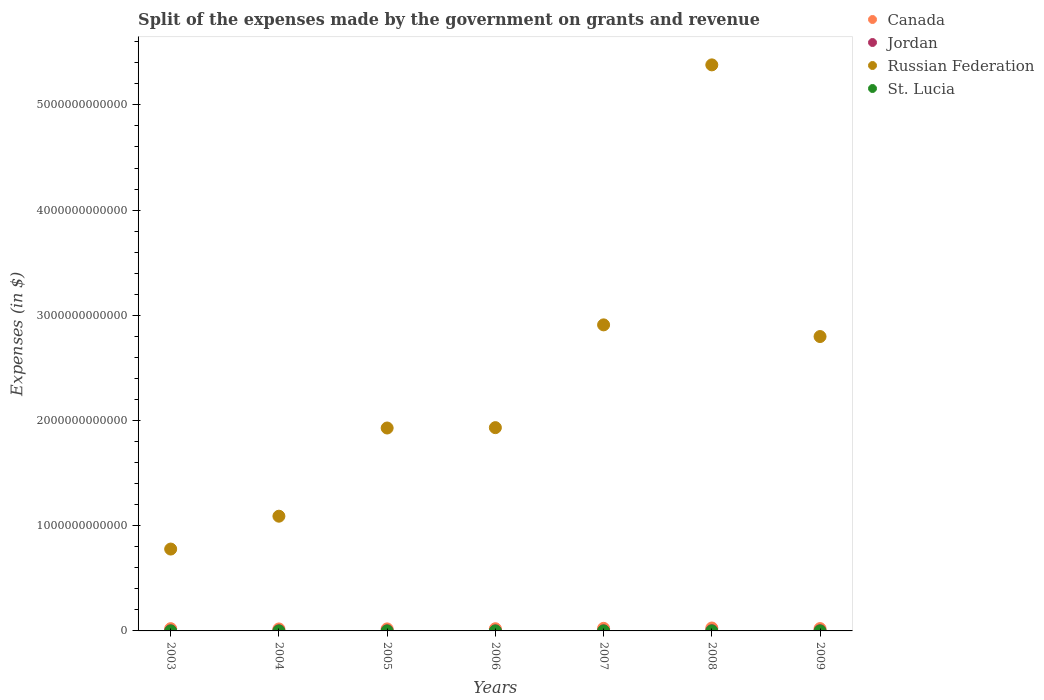How many different coloured dotlines are there?
Provide a succinct answer. 4. Is the number of dotlines equal to the number of legend labels?
Give a very brief answer. Yes. What is the expenses made by the government on grants and revenue in Jordan in 2005?
Your answer should be compact. 8.67e+08. Across all years, what is the maximum expenses made by the government on grants and revenue in Canada?
Provide a succinct answer. 2.77e+1. Across all years, what is the minimum expenses made by the government on grants and revenue in Canada?
Make the answer very short. 1.88e+1. What is the total expenses made by the government on grants and revenue in Russian Federation in the graph?
Offer a terse response. 1.68e+13. What is the difference between the expenses made by the government on grants and revenue in Russian Federation in 2003 and that in 2004?
Offer a very short reply. -3.12e+11. What is the difference between the expenses made by the government on grants and revenue in Jordan in 2003 and the expenses made by the government on grants and revenue in Canada in 2005?
Keep it short and to the point. -1.82e+1. What is the average expenses made by the government on grants and revenue in Russian Federation per year?
Provide a short and direct response. 2.40e+12. In the year 2005, what is the difference between the expenses made by the government on grants and revenue in Canada and expenses made by the government on grants and revenue in St. Lucia?
Your answer should be very brief. 1.92e+1. In how many years, is the expenses made by the government on grants and revenue in Canada greater than 1200000000000 $?
Ensure brevity in your answer.  0. What is the ratio of the expenses made by the government on grants and revenue in Canada in 2006 to that in 2009?
Provide a succinct answer. 0.94. What is the difference between the highest and the second highest expenses made by the government on grants and revenue in Russian Federation?
Provide a short and direct response. 2.47e+12. What is the difference between the highest and the lowest expenses made by the government on grants and revenue in Russian Federation?
Give a very brief answer. 4.60e+12. Is the sum of the expenses made by the government on grants and revenue in Russian Federation in 2003 and 2009 greater than the maximum expenses made by the government on grants and revenue in Canada across all years?
Your answer should be very brief. Yes. Is it the case that in every year, the sum of the expenses made by the government on grants and revenue in Jordan and expenses made by the government on grants and revenue in Russian Federation  is greater than the sum of expenses made by the government on grants and revenue in St. Lucia and expenses made by the government on grants and revenue in Canada?
Give a very brief answer. Yes. Is it the case that in every year, the sum of the expenses made by the government on grants and revenue in St. Lucia and expenses made by the government on grants and revenue in Canada  is greater than the expenses made by the government on grants and revenue in Jordan?
Offer a very short reply. Yes. Does the expenses made by the government on grants and revenue in Canada monotonically increase over the years?
Your answer should be very brief. No. Is the expenses made by the government on grants and revenue in Canada strictly less than the expenses made by the government on grants and revenue in St. Lucia over the years?
Your answer should be very brief. No. How many dotlines are there?
Your answer should be very brief. 4. What is the difference between two consecutive major ticks on the Y-axis?
Ensure brevity in your answer.  1.00e+12. Does the graph contain grids?
Your answer should be compact. No. How are the legend labels stacked?
Your answer should be very brief. Vertical. What is the title of the graph?
Your answer should be compact. Split of the expenses made by the government on grants and revenue. Does "Belgium" appear as one of the legend labels in the graph?
Offer a terse response. No. What is the label or title of the Y-axis?
Provide a short and direct response. Expenses (in $). What is the Expenses (in $) of Canada in 2003?
Ensure brevity in your answer.  2.14e+1. What is the Expenses (in $) of Jordan in 2003?
Your answer should be compact. 1.03e+09. What is the Expenses (in $) in Russian Federation in 2003?
Provide a succinct answer. 7.78e+11. What is the Expenses (in $) of St. Lucia in 2003?
Provide a succinct answer. 4.30e+07. What is the Expenses (in $) of Canada in 2004?
Offer a very short reply. 1.88e+1. What is the Expenses (in $) of Jordan in 2004?
Your answer should be very brief. 1.04e+09. What is the Expenses (in $) in Russian Federation in 2004?
Provide a short and direct response. 1.09e+12. What is the Expenses (in $) in Canada in 2005?
Offer a terse response. 1.92e+1. What is the Expenses (in $) of Jordan in 2005?
Offer a very short reply. 8.67e+08. What is the Expenses (in $) in Russian Federation in 2005?
Ensure brevity in your answer.  1.93e+12. What is the Expenses (in $) of St. Lucia in 2005?
Offer a very short reply. 4.20e+06. What is the Expenses (in $) in Canada in 2006?
Offer a very short reply. 2.09e+1. What is the Expenses (in $) of Jordan in 2006?
Offer a terse response. 8.31e+08. What is the Expenses (in $) of Russian Federation in 2006?
Your response must be concise. 1.93e+12. What is the Expenses (in $) of St. Lucia in 2006?
Keep it short and to the point. 3.30e+06. What is the Expenses (in $) in Canada in 2007?
Give a very brief answer. 2.45e+1. What is the Expenses (in $) in Jordan in 2007?
Your response must be concise. 9.58e+08. What is the Expenses (in $) of Russian Federation in 2007?
Give a very brief answer. 2.91e+12. What is the Expenses (in $) of St. Lucia in 2007?
Provide a short and direct response. 9.30e+06. What is the Expenses (in $) of Canada in 2008?
Provide a succinct answer. 2.77e+1. What is the Expenses (in $) of Jordan in 2008?
Your response must be concise. 1.96e+09. What is the Expenses (in $) of Russian Federation in 2008?
Give a very brief answer. 5.38e+12. What is the Expenses (in $) of St. Lucia in 2008?
Your answer should be compact. 2.07e+07. What is the Expenses (in $) in Canada in 2009?
Offer a very short reply. 2.21e+1. What is the Expenses (in $) in Jordan in 2009?
Keep it short and to the point. 1.62e+09. What is the Expenses (in $) in Russian Federation in 2009?
Provide a succinct answer. 2.80e+12. What is the Expenses (in $) of St. Lucia in 2009?
Offer a very short reply. 2.59e+07. Across all years, what is the maximum Expenses (in $) of Canada?
Provide a short and direct response. 2.77e+1. Across all years, what is the maximum Expenses (in $) in Jordan?
Ensure brevity in your answer.  1.96e+09. Across all years, what is the maximum Expenses (in $) of Russian Federation?
Provide a short and direct response. 5.38e+12. Across all years, what is the maximum Expenses (in $) in St. Lucia?
Give a very brief answer. 4.30e+07. Across all years, what is the minimum Expenses (in $) in Canada?
Provide a short and direct response. 1.88e+1. Across all years, what is the minimum Expenses (in $) of Jordan?
Provide a succinct answer. 8.31e+08. Across all years, what is the minimum Expenses (in $) of Russian Federation?
Make the answer very short. 7.78e+11. Across all years, what is the minimum Expenses (in $) of St. Lucia?
Make the answer very short. 3.30e+06. What is the total Expenses (in $) of Canada in the graph?
Make the answer very short. 1.55e+11. What is the total Expenses (in $) in Jordan in the graph?
Offer a very short reply. 8.30e+09. What is the total Expenses (in $) in Russian Federation in the graph?
Provide a succinct answer. 1.68e+13. What is the total Expenses (in $) in St. Lucia in the graph?
Offer a very short reply. 1.12e+08. What is the difference between the Expenses (in $) in Canada in 2003 and that in 2004?
Offer a terse response. 2.53e+09. What is the difference between the Expenses (in $) in Jordan in 2003 and that in 2004?
Your answer should be compact. -9.27e+06. What is the difference between the Expenses (in $) of Russian Federation in 2003 and that in 2004?
Your answer should be compact. -3.12e+11. What is the difference between the Expenses (in $) in St. Lucia in 2003 and that in 2004?
Give a very brief answer. 3.70e+07. What is the difference between the Expenses (in $) of Canada in 2003 and that in 2005?
Offer a very short reply. 2.18e+09. What is the difference between the Expenses (in $) of Jordan in 2003 and that in 2005?
Your response must be concise. 1.62e+08. What is the difference between the Expenses (in $) of Russian Federation in 2003 and that in 2005?
Provide a short and direct response. -1.15e+12. What is the difference between the Expenses (in $) of St. Lucia in 2003 and that in 2005?
Keep it short and to the point. 3.88e+07. What is the difference between the Expenses (in $) of Canada in 2003 and that in 2006?
Provide a succinct answer. 4.96e+08. What is the difference between the Expenses (in $) in Jordan in 2003 and that in 2006?
Make the answer very short. 1.98e+08. What is the difference between the Expenses (in $) in Russian Federation in 2003 and that in 2006?
Keep it short and to the point. -1.15e+12. What is the difference between the Expenses (in $) in St. Lucia in 2003 and that in 2006?
Provide a succinct answer. 3.97e+07. What is the difference between the Expenses (in $) in Canada in 2003 and that in 2007?
Keep it short and to the point. -3.13e+09. What is the difference between the Expenses (in $) in Jordan in 2003 and that in 2007?
Your answer should be very brief. 7.03e+07. What is the difference between the Expenses (in $) of Russian Federation in 2003 and that in 2007?
Give a very brief answer. -2.13e+12. What is the difference between the Expenses (in $) in St. Lucia in 2003 and that in 2007?
Make the answer very short. 3.37e+07. What is the difference between the Expenses (in $) of Canada in 2003 and that in 2008?
Offer a terse response. -6.36e+09. What is the difference between the Expenses (in $) in Jordan in 2003 and that in 2008?
Give a very brief answer. -9.31e+08. What is the difference between the Expenses (in $) of Russian Federation in 2003 and that in 2008?
Your response must be concise. -4.60e+12. What is the difference between the Expenses (in $) of St. Lucia in 2003 and that in 2008?
Your answer should be compact. 2.23e+07. What is the difference between the Expenses (in $) in Canada in 2003 and that in 2009?
Your response must be concise. -7.74e+08. What is the difference between the Expenses (in $) of Jordan in 2003 and that in 2009?
Provide a short and direct response. -5.93e+08. What is the difference between the Expenses (in $) of Russian Federation in 2003 and that in 2009?
Provide a succinct answer. -2.02e+12. What is the difference between the Expenses (in $) of St. Lucia in 2003 and that in 2009?
Ensure brevity in your answer.  1.71e+07. What is the difference between the Expenses (in $) of Canada in 2004 and that in 2005?
Offer a terse response. -3.55e+08. What is the difference between the Expenses (in $) of Jordan in 2004 and that in 2005?
Provide a succinct answer. 1.71e+08. What is the difference between the Expenses (in $) in Russian Federation in 2004 and that in 2005?
Provide a short and direct response. -8.38e+11. What is the difference between the Expenses (in $) of St. Lucia in 2004 and that in 2005?
Offer a terse response. 1.80e+06. What is the difference between the Expenses (in $) in Canada in 2004 and that in 2006?
Your answer should be compact. -2.04e+09. What is the difference between the Expenses (in $) of Jordan in 2004 and that in 2006?
Keep it short and to the point. 2.07e+08. What is the difference between the Expenses (in $) of Russian Federation in 2004 and that in 2006?
Your answer should be compact. -8.42e+11. What is the difference between the Expenses (in $) of St. Lucia in 2004 and that in 2006?
Offer a terse response. 2.70e+06. What is the difference between the Expenses (in $) of Canada in 2004 and that in 2007?
Your answer should be compact. -5.66e+09. What is the difference between the Expenses (in $) in Jordan in 2004 and that in 2007?
Provide a short and direct response. 7.96e+07. What is the difference between the Expenses (in $) of Russian Federation in 2004 and that in 2007?
Ensure brevity in your answer.  -1.82e+12. What is the difference between the Expenses (in $) of St. Lucia in 2004 and that in 2007?
Keep it short and to the point. -3.30e+06. What is the difference between the Expenses (in $) in Canada in 2004 and that in 2008?
Keep it short and to the point. -8.90e+09. What is the difference between the Expenses (in $) of Jordan in 2004 and that in 2008?
Offer a terse response. -9.22e+08. What is the difference between the Expenses (in $) in Russian Federation in 2004 and that in 2008?
Provide a short and direct response. -4.29e+12. What is the difference between the Expenses (in $) of St. Lucia in 2004 and that in 2008?
Ensure brevity in your answer.  -1.47e+07. What is the difference between the Expenses (in $) of Canada in 2004 and that in 2009?
Ensure brevity in your answer.  -3.31e+09. What is the difference between the Expenses (in $) of Jordan in 2004 and that in 2009?
Give a very brief answer. -5.83e+08. What is the difference between the Expenses (in $) in Russian Federation in 2004 and that in 2009?
Provide a short and direct response. -1.71e+12. What is the difference between the Expenses (in $) in St. Lucia in 2004 and that in 2009?
Provide a succinct answer. -1.99e+07. What is the difference between the Expenses (in $) of Canada in 2005 and that in 2006?
Your answer should be very brief. -1.68e+09. What is the difference between the Expenses (in $) of Jordan in 2005 and that in 2006?
Your answer should be compact. 3.61e+07. What is the difference between the Expenses (in $) in Russian Federation in 2005 and that in 2006?
Your answer should be compact. -3.47e+09. What is the difference between the Expenses (in $) of Canada in 2005 and that in 2007?
Your response must be concise. -5.30e+09. What is the difference between the Expenses (in $) of Jordan in 2005 and that in 2007?
Your answer should be very brief. -9.13e+07. What is the difference between the Expenses (in $) of Russian Federation in 2005 and that in 2007?
Ensure brevity in your answer.  -9.80e+11. What is the difference between the Expenses (in $) of St. Lucia in 2005 and that in 2007?
Your answer should be very brief. -5.10e+06. What is the difference between the Expenses (in $) in Canada in 2005 and that in 2008?
Provide a succinct answer. -8.54e+09. What is the difference between the Expenses (in $) of Jordan in 2005 and that in 2008?
Provide a succinct answer. -1.09e+09. What is the difference between the Expenses (in $) in Russian Federation in 2005 and that in 2008?
Your answer should be very brief. -3.45e+12. What is the difference between the Expenses (in $) of St. Lucia in 2005 and that in 2008?
Make the answer very short. -1.65e+07. What is the difference between the Expenses (in $) of Canada in 2005 and that in 2009?
Provide a short and direct response. -2.95e+09. What is the difference between the Expenses (in $) of Jordan in 2005 and that in 2009?
Offer a terse response. -7.54e+08. What is the difference between the Expenses (in $) of Russian Federation in 2005 and that in 2009?
Offer a very short reply. -8.69e+11. What is the difference between the Expenses (in $) of St. Lucia in 2005 and that in 2009?
Give a very brief answer. -2.17e+07. What is the difference between the Expenses (in $) of Canada in 2006 and that in 2007?
Provide a short and direct response. -3.62e+09. What is the difference between the Expenses (in $) of Jordan in 2006 and that in 2007?
Your response must be concise. -1.27e+08. What is the difference between the Expenses (in $) in Russian Federation in 2006 and that in 2007?
Make the answer very short. -9.77e+11. What is the difference between the Expenses (in $) of St. Lucia in 2006 and that in 2007?
Ensure brevity in your answer.  -6.00e+06. What is the difference between the Expenses (in $) in Canada in 2006 and that in 2008?
Your answer should be very brief. -6.86e+09. What is the difference between the Expenses (in $) of Jordan in 2006 and that in 2008?
Provide a succinct answer. -1.13e+09. What is the difference between the Expenses (in $) of Russian Federation in 2006 and that in 2008?
Provide a succinct answer. -3.45e+12. What is the difference between the Expenses (in $) in St. Lucia in 2006 and that in 2008?
Your answer should be very brief. -1.74e+07. What is the difference between the Expenses (in $) in Canada in 2006 and that in 2009?
Ensure brevity in your answer.  -1.27e+09. What is the difference between the Expenses (in $) of Jordan in 2006 and that in 2009?
Your answer should be compact. -7.90e+08. What is the difference between the Expenses (in $) in Russian Federation in 2006 and that in 2009?
Your answer should be very brief. -8.66e+11. What is the difference between the Expenses (in $) of St. Lucia in 2006 and that in 2009?
Make the answer very short. -2.26e+07. What is the difference between the Expenses (in $) in Canada in 2007 and that in 2008?
Offer a terse response. -3.24e+09. What is the difference between the Expenses (in $) in Jordan in 2007 and that in 2008?
Make the answer very short. -1.00e+09. What is the difference between the Expenses (in $) of Russian Federation in 2007 and that in 2008?
Offer a very short reply. -2.47e+12. What is the difference between the Expenses (in $) of St. Lucia in 2007 and that in 2008?
Make the answer very short. -1.14e+07. What is the difference between the Expenses (in $) of Canada in 2007 and that in 2009?
Your answer should be very brief. 2.35e+09. What is the difference between the Expenses (in $) in Jordan in 2007 and that in 2009?
Make the answer very short. -6.63e+08. What is the difference between the Expenses (in $) of Russian Federation in 2007 and that in 2009?
Offer a terse response. 1.11e+11. What is the difference between the Expenses (in $) of St. Lucia in 2007 and that in 2009?
Give a very brief answer. -1.66e+07. What is the difference between the Expenses (in $) in Canada in 2008 and that in 2009?
Make the answer very short. 5.59e+09. What is the difference between the Expenses (in $) of Jordan in 2008 and that in 2009?
Your answer should be compact. 3.38e+08. What is the difference between the Expenses (in $) of Russian Federation in 2008 and that in 2009?
Provide a short and direct response. 2.58e+12. What is the difference between the Expenses (in $) of St. Lucia in 2008 and that in 2009?
Offer a terse response. -5.20e+06. What is the difference between the Expenses (in $) of Canada in 2003 and the Expenses (in $) of Jordan in 2004?
Provide a succinct answer. 2.03e+1. What is the difference between the Expenses (in $) in Canada in 2003 and the Expenses (in $) in Russian Federation in 2004?
Give a very brief answer. -1.07e+12. What is the difference between the Expenses (in $) in Canada in 2003 and the Expenses (in $) in St. Lucia in 2004?
Your answer should be very brief. 2.14e+1. What is the difference between the Expenses (in $) of Jordan in 2003 and the Expenses (in $) of Russian Federation in 2004?
Offer a very short reply. -1.09e+12. What is the difference between the Expenses (in $) in Jordan in 2003 and the Expenses (in $) in St. Lucia in 2004?
Ensure brevity in your answer.  1.02e+09. What is the difference between the Expenses (in $) of Russian Federation in 2003 and the Expenses (in $) of St. Lucia in 2004?
Offer a very short reply. 7.78e+11. What is the difference between the Expenses (in $) in Canada in 2003 and the Expenses (in $) in Jordan in 2005?
Your answer should be compact. 2.05e+1. What is the difference between the Expenses (in $) of Canada in 2003 and the Expenses (in $) of Russian Federation in 2005?
Offer a terse response. -1.91e+12. What is the difference between the Expenses (in $) of Canada in 2003 and the Expenses (in $) of St. Lucia in 2005?
Ensure brevity in your answer.  2.14e+1. What is the difference between the Expenses (in $) of Jordan in 2003 and the Expenses (in $) of Russian Federation in 2005?
Offer a terse response. -1.93e+12. What is the difference between the Expenses (in $) in Jordan in 2003 and the Expenses (in $) in St. Lucia in 2005?
Provide a succinct answer. 1.02e+09. What is the difference between the Expenses (in $) of Russian Federation in 2003 and the Expenses (in $) of St. Lucia in 2005?
Ensure brevity in your answer.  7.78e+11. What is the difference between the Expenses (in $) of Canada in 2003 and the Expenses (in $) of Jordan in 2006?
Give a very brief answer. 2.05e+1. What is the difference between the Expenses (in $) of Canada in 2003 and the Expenses (in $) of Russian Federation in 2006?
Give a very brief answer. -1.91e+12. What is the difference between the Expenses (in $) in Canada in 2003 and the Expenses (in $) in St. Lucia in 2006?
Provide a succinct answer. 2.14e+1. What is the difference between the Expenses (in $) of Jordan in 2003 and the Expenses (in $) of Russian Federation in 2006?
Keep it short and to the point. -1.93e+12. What is the difference between the Expenses (in $) of Jordan in 2003 and the Expenses (in $) of St. Lucia in 2006?
Make the answer very short. 1.02e+09. What is the difference between the Expenses (in $) of Russian Federation in 2003 and the Expenses (in $) of St. Lucia in 2006?
Provide a succinct answer. 7.78e+11. What is the difference between the Expenses (in $) of Canada in 2003 and the Expenses (in $) of Jordan in 2007?
Offer a very short reply. 2.04e+1. What is the difference between the Expenses (in $) of Canada in 2003 and the Expenses (in $) of Russian Federation in 2007?
Give a very brief answer. -2.89e+12. What is the difference between the Expenses (in $) in Canada in 2003 and the Expenses (in $) in St. Lucia in 2007?
Provide a succinct answer. 2.13e+1. What is the difference between the Expenses (in $) in Jordan in 2003 and the Expenses (in $) in Russian Federation in 2007?
Your answer should be compact. -2.91e+12. What is the difference between the Expenses (in $) in Jordan in 2003 and the Expenses (in $) in St. Lucia in 2007?
Give a very brief answer. 1.02e+09. What is the difference between the Expenses (in $) in Russian Federation in 2003 and the Expenses (in $) in St. Lucia in 2007?
Your response must be concise. 7.78e+11. What is the difference between the Expenses (in $) of Canada in 2003 and the Expenses (in $) of Jordan in 2008?
Keep it short and to the point. 1.94e+1. What is the difference between the Expenses (in $) of Canada in 2003 and the Expenses (in $) of Russian Federation in 2008?
Your answer should be very brief. -5.36e+12. What is the difference between the Expenses (in $) of Canada in 2003 and the Expenses (in $) of St. Lucia in 2008?
Keep it short and to the point. 2.13e+1. What is the difference between the Expenses (in $) of Jordan in 2003 and the Expenses (in $) of Russian Federation in 2008?
Your answer should be very brief. -5.38e+12. What is the difference between the Expenses (in $) of Jordan in 2003 and the Expenses (in $) of St. Lucia in 2008?
Offer a terse response. 1.01e+09. What is the difference between the Expenses (in $) of Russian Federation in 2003 and the Expenses (in $) of St. Lucia in 2008?
Ensure brevity in your answer.  7.78e+11. What is the difference between the Expenses (in $) of Canada in 2003 and the Expenses (in $) of Jordan in 2009?
Give a very brief answer. 1.97e+1. What is the difference between the Expenses (in $) in Canada in 2003 and the Expenses (in $) in Russian Federation in 2009?
Keep it short and to the point. -2.78e+12. What is the difference between the Expenses (in $) in Canada in 2003 and the Expenses (in $) in St. Lucia in 2009?
Offer a terse response. 2.13e+1. What is the difference between the Expenses (in $) of Jordan in 2003 and the Expenses (in $) of Russian Federation in 2009?
Provide a succinct answer. -2.80e+12. What is the difference between the Expenses (in $) in Jordan in 2003 and the Expenses (in $) in St. Lucia in 2009?
Your answer should be very brief. 1.00e+09. What is the difference between the Expenses (in $) of Russian Federation in 2003 and the Expenses (in $) of St. Lucia in 2009?
Offer a terse response. 7.78e+11. What is the difference between the Expenses (in $) of Canada in 2004 and the Expenses (in $) of Jordan in 2005?
Keep it short and to the point. 1.80e+1. What is the difference between the Expenses (in $) of Canada in 2004 and the Expenses (in $) of Russian Federation in 2005?
Provide a short and direct response. -1.91e+12. What is the difference between the Expenses (in $) in Canada in 2004 and the Expenses (in $) in St. Lucia in 2005?
Make the answer very short. 1.88e+1. What is the difference between the Expenses (in $) in Jordan in 2004 and the Expenses (in $) in Russian Federation in 2005?
Give a very brief answer. -1.93e+12. What is the difference between the Expenses (in $) in Jordan in 2004 and the Expenses (in $) in St. Lucia in 2005?
Ensure brevity in your answer.  1.03e+09. What is the difference between the Expenses (in $) in Russian Federation in 2004 and the Expenses (in $) in St. Lucia in 2005?
Offer a very short reply. 1.09e+12. What is the difference between the Expenses (in $) of Canada in 2004 and the Expenses (in $) of Jordan in 2006?
Provide a succinct answer. 1.80e+1. What is the difference between the Expenses (in $) of Canada in 2004 and the Expenses (in $) of Russian Federation in 2006?
Offer a very short reply. -1.91e+12. What is the difference between the Expenses (in $) in Canada in 2004 and the Expenses (in $) in St. Lucia in 2006?
Make the answer very short. 1.88e+1. What is the difference between the Expenses (in $) in Jordan in 2004 and the Expenses (in $) in Russian Federation in 2006?
Keep it short and to the point. -1.93e+12. What is the difference between the Expenses (in $) of Jordan in 2004 and the Expenses (in $) of St. Lucia in 2006?
Offer a terse response. 1.03e+09. What is the difference between the Expenses (in $) in Russian Federation in 2004 and the Expenses (in $) in St. Lucia in 2006?
Offer a terse response. 1.09e+12. What is the difference between the Expenses (in $) in Canada in 2004 and the Expenses (in $) in Jordan in 2007?
Your answer should be compact. 1.79e+1. What is the difference between the Expenses (in $) of Canada in 2004 and the Expenses (in $) of Russian Federation in 2007?
Provide a short and direct response. -2.89e+12. What is the difference between the Expenses (in $) of Canada in 2004 and the Expenses (in $) of St. Lucia in 2007?
Ensure brevity in your answer.  1.88e+1. What is the difference between the Expenses (in $) in Jordan in 2004 and the Expenses (in $) in Russian Federation in 2007?
Your answer should be compact. -2.91e+12. What is the difference between the Expenses (in $) in Jordan in 2004 and the Expenses (in $) in St. Lucia in 2007?
Keep it short and to the point. 1.03e+09. What is the difference between the Expenses (in $) in Russian Federation in 2004 and the Expenses (in $) in St. Lucia in 2007?
Ensure brevity in your answer.  1.09e+12. What is the difference between the Expenses (in $) of Canada in 2004 and the Expenses (in $) of Jordan in 2008?
Offer a terse response. 1.69e+1. What is the difference between the Expenses (in $) in Canada in 2004 and the Expenses (in $) in Russian Federation in 2008?
Offer a very short reply. -5.36e+12. What is the difference between the Expenses (in $) in Canada in 2004 and the Expenses (in $) in St. Lucia in 2008?
Your answer should be compact. 1.88e+1. What is the difference between the Expenses (in $) in Jordan in 2004 and the Expenses (in $) in Russian Federation in 2008?
Offer a very short reply. -5.38e+12. What is the difference between the Expenses (in $) of Jordan in 2004 and the Expenses (in $) of St. Lucia in 2008?
Provide a short and direct response. 1.02e+09. What is the difference between the Expenses (in $) of Russian Federation in 2004 and the Expenses (in $) of St. Lucia in 2008?
Offer a terse response. 1.09e+12. What is the difference between the Expenses (in $) of Canada in 2004 and the Expenses (in $) of Jordan in 2009?
Offer a very short reply. 1.72e+1. What is the difference between the Expenses (in $) in Canada in 2004 and the Expenses (in $) in Russian Federation in 2009?
Your answer should be compact. -2.78e+12. What is the difference between the Expenses (in $) in Canada in 2004 and the Expenses (in $) in St. Lucia in 2009?
Your answer should be compact. 1.88e+1. What is the difference between the Expenses (in $) of Jordan in 2004 and the Expenses (in $) of Russian Federation in 2009?
Make the answer very short. -2.80e+12. What is the difference between the Expenses (in $) of Jordan in 2004 and the Expenses (in $) of St. Lucia in 2009?
Ensure brevity in your answer.  1.01e+09. What is the difference between the Expenses (in $) of Russian Federation in 2004 and the Expenses (in $) of St. Lucia in 2009?
Ensure brevity in your answer.  1.09e+12. What is the difference between the Expenses (in $) of Canada in 2005 and the Expenses (in $) of Jordan in 2006?
Offer a very short reply. 1.84e+1. What is the difference between the Expenses (in $) of Canada in 2005 and the Expenses (in $) of Russian Federation in 2006?
Ensure brevity in your answer.  -1.91e+12. What is the difference between the Expenses (in $) in Canada in 2005 and the Expenses (in $) in St. Lucia in 2006?
Offer a very short reply. 1.92e+1. What is the difference between the Expenses (in $) of Jordan in 2005 and the Expenses (in $) of Russian Federation in 2006?
Your answer should be very brief. -1.93e+12. What is the difference between the Expenses (in $) of Jordan in 2005 and the Expenses (in $) of St. Lucia in 2006?
Offer a terse response. 8.63e+08. What is the difference between the Expenses (in $) in Russian Federation in 2005 and the Expenses (in $) in St. Lucia in 2006?
Your response must be concise. 1.93e+12. What is the difference between the Expenses (in $) in Canada in 2005 and the Expenses (in $) in Jordan in 2007?
Give a very brief answer. 1.82e+1. What is the difference between the Expenses (in $) of Canada in 2005 and the Expenses (in $) of Russian Federation in 2007?
Make the answer very short. -2.89e+12. What is the difference between the Expenses (in $) in Canada in 2005 and the Expenses (in $) in St. Lucia in 2007?
Your answer should be compact. 1.92e+1. What is the difference between the Expenses (in $) in Jordan in 2005 and the Expenses (in $) in Russian Federation in 2007?
Ensure brevity in your answer.  -2.91e+12. What is the difference between the Expenses (in $) of Jordan in 2005 and the Expenses (in $) of St. Lucia in 2007?
Offer a very short reply. 8.57e+08. What is the difference between the Expenses (in $) in Russian Federation in 2005 and the Expenses (in $) in St. Lucia in 2007?
Ensure brevity in your answer.  1.93e+12. What is the difference between the Expenses (in $) in Canada in 2005 and the Expenses (in $) in Jordan in 2008?
Your answer should be compact. 1.72e+1. What is the difference between the Expenses (in $) of Canada in 2005 and the Expenses (in $) of Russian Federation in 2008?
Make the answer very short. -5.36e+12. What is the difference between the Expenses (in $) of Canada in 2005 and the Expenses (in $) of St. Lucia in 2008?
Make the answer very short. 1.92e+1. What is the difference between the Expenses (in $) of Jordan in 2005 and the Expenses (in $) of Russian Federation in 2008?
Your answer should be compact. -5.38e+12. What is the difference between the Expenses (in $) of Jordan in 2005 and the Expenses (in $) of St. Lucia in 2008?
Make the answer very short. 8.46e+08. What is the difference between the Expenses (in $) in Russian Federation in 2005 and the Expenses (in $) in St. Lucia in 2008?
Give a very brief answer. 1.93e+12. What is the difference between the Expenses (in $) in Canada in 2005 and the Expenses (in $) in Jordan in 2009?
Your response must be concise. 1.76e+1. What is the difference between the Expenses (in $) of Canada in 2005 and the Expenses (in $) of Russian Federation in 2009?
Make the answer very short. -2.78e+12. What is the difference between the Expenses (in $) of Canada in 2005 and the Expenses (in $) of St. Lucia in 2009?
Your response must be concise. 1.92e+1. What is the difference between the Expenses (in $) of Jordan in 2005 and the Expenses (in $) of Russian Federation in 2009?
Your response must be concise. -2.80e+12. What is the difference between the Expenses (in $) in Jordan in 2005 and the Expenses (in $) in St. Lucia in 2009?
Provide a succinct answer. 8.41e+08. What is the difference between the Expenses (in $) in Russian Federation in 2005 and the Expenses (in $) in St. Lucia in 2009?
Keep it short and to the point. 1.93e+12. What is the difference between the Expenses (in $) in Canada in 2006 and the Expenses (in $) in Jordan in 2007?
Ensure brevity in your answer.  1.99e+1. What is the difference between the Expenses (in $) of Canada in 2006 and the Expenses (in $) of Russian Federation in 2007?
Offer a very short reply. -2.89e+12. What is the difference between the Expenses (in $) of Canada in 2006 and the Expenses (in $) of St. Lucia in 2007?
Provide a short and direct response. 2.09e+1. What is the difference between the Expenses (in $) in Jordan in 2006 and the Expenses (in $) in Russian Federation in 2007?
Your answer should be very brief. -2.91e+12. What is the difference between the Expenses (in $) of Jordan in 2006 and the Expenses (in $) of St. Lucia in 2007?
Your answer should be compact. 8.21e+08. What is the difference between the Expenses (in $) in Russian Federation in 2006 and the Expenses (in $) in St. Lucia in 2007?
Offer a terse response. 1.93e+12. What is the difference between the Expenses (in $) of Canada in 2006 and the Expenses (in $) of Jordan in 2008?
Provide a succinct answer. 1.89e+1. What is the difference between the Expenses (in $) of Canada in 2006 and the Expenses (in $) of Russian Federation in 2008?
Give a very brief answer. -5.36e+12. What is the difference between the Expenses (in $) of Canada in 2006 and the Expenses (in $) of St. Lucia in 2008?
Your response must be concise. 2.08e+1. What is the difference between the Expenses (in $) of Jordan in 2006 and the Expenses (in $) of Russian Federation in 2008?
Offer a very short reply. -5.38e+12. What is the difference between the Expenses (in $) of Jordan in 2006 and the Expenses (in $) of St. Lucia in 2008?
Give a very brief answer. 8.10e+08. What is the difference between the Expenses (in $) of Russian Federation in 2006 and the Expenses (in $) of St. Lucia in 2008?
Ensure brevity in your answer.  1.93e+12. What is the difference between the Expenses (in $) in Canada in 2006 and the Expenses (in $) in Jordan in 2009?
Offer a terse response. 1.92e+1. What is the difference between the Expenses (in $) of Canada in 2006 and the Expenses (in $) of Russian Federation in 2009?
Your response must be concise. -2.78e+12. What is the difference between the Expenses (in $) in Canada in 2006 and the Expenses (in $) in St. Lucia in 2009?
Give a very brief answer. 2.08e+1. What is the difference between the Expenses (in $) of Jordan in 2006 and the Expenses (in $) of Russian Federation in 2009?
Your response must be concise. -2.80e+12. What is the difference between the Expenses (in $) in Jordan in 2006 and the Expenses (in $) in St. Lucia in 2009?
Keep it short and to the point. 8.05e+08. What is the difference between the Expenses (in $) in Russian Federation in 2006 and the Expenses (in $) in St. Lucia in 2009?
Provide a succinct answer. 1.93e+12. What is the difference between the Expenses (in $) in Canada in 2007 and the Expenses (in $) in Jordan in 2008?
Your response must be concise. 2.25e+1. What is the difference between the Expenses (in $) in Canada in 2007 and the Expenses (in $) in Russian Federation in 2008?
Keep it short and to the point. -5.36e+12. What is the difference between the Expenses (in $) in Canada in 2007 and the Expenses (in $) in St. Lucia in 2008?
Provide a short and direct response. 2.45e+1. What is the difference between the Expenses (in $) of Jordan in 2007 and the Expenses (in $) of Russian Federation in 2008?
Give a very brief answer. -5.38e+12. What is the difference between the Expenses (in $) in Jordan in 2007 and the Expenses (in $) in St. Lucia in 2008?
Provide a short and direct response. 9.37e+08. What is the difference between the Expenses (in $) of Russian Federation in 2007 and the Expenses (in $) of St. Lucia in 2008?
Ensure brevity in your answer.  2.91e+12. What is the difference between the Expenses (in $) in Canada in 2007 and the Expenses (in $) in Jordan in 2009?
Your answer should be very brief. 2.29e+1. What is the difference between the Expenses (in $) of Canada in 2007 and the Expenses (in $) of Russian Federation in 2009?
Provide a short and direct response. -2.77e+12. What is the difference between the Expenses (in $) in Canada in 2007 and the Expenses (in $) in St. Lucia in 2009?
Provide a short and direct response. 2.45e+1. What is the difference between the Expenses (in $) in Jordan in 2007 and the Expenses (in $) in Russian Federation in 2009?
Provide a short and direct response. -2.80e+12. What is the difference between the Expenses (in $) of Jordan in 2007 and the Expenses (in $) of St. Lucia in 2009?
Give a very brief answer. 9.32e+08. What is the difference between the Expenses (in $) of Russian Federation in 2007 and the Expenses (in $) of St. Lucia in 2009?
Give a very brief answer. 2.91e+12. What is the difference between the Expenses (in $) in Canada in 2008 and the Expenses (in $) in Jordan in 2009?
Your response must be concise. 2.61e+1. What is the difference between the Expenses (in $) in Canada in 2008 and the Expenses (in $) in Russian Federation in 2009?
Provide a short and direct response. -2.77e+12. What is the difference between the Expenses (in $) of Canada in 2008 and the Expenses (in $) of St. Lucia in 2009?
Keep it short and to the point. 2.77e+1. What is the difference between the Expenses (in $) in Jordan in 2008 and the Expenses (in $) in Russian Federation in 2009?
Your answer should be compact. -2.80e+12. What is the difference between the Expenses (in $) in Jordan in 2008 and the Expenses (in $) in St. Lucia in 2009?
Offer a terse response. 1.93e+09. What is the difference between the Expenses (in $) of Russian Federation in 2008 and the Expenses (in $) of St. Lucia in 2009?
Provide a succinct answer. 5.38e+12. What is the average Expenses (in $) in Canada per year?
Ensure brevity in your answer.  2.21e+1. What is the average Expenses (in $) of Jordan per year?
Your answer should be compact. 1.19e+09. What is the average Expenses (in $) in Russian Federation per year?
Your answer should be very brief. 2.40e+12. What is the average Expenses (in $) in St. Lucia per year?
Your answer should be compact. 1.61e+07. In the year 2003, what is the difference between the Expenses (in $) of Canada and Expenses (in $) of Jordan?
Your answer should be very brief. 2.03e+1. In the year 2003, what is the difference between the Expenses (in $) in Canada and Expenses (in $) in Russian Federation?
Provide a succinct answer. -7.57e+11. In the year 2003, what is the difference between the Expenses (in $) in Canada and Expenses (in $) in St. Lucia?
Keep it short and to the point. 2.13e+1. In the year 2003, what is the difference between the Expenses (in $) of Jordan and Expenses (in $) of Russian Federation?
Your answer should be compact. -7.77e+11. In the year 2003, what is the difference between the Expenses (in $) in Jordan and Expenses (in $) in St. Lucia?
Offer a very short reply. 9.85e+08. In the year 2003, what is the difference between the Expenses (in $) in Russian Federation and Expenses (in $) in St. Lucia?
Offer a terse response. 7.78e+11. In the year 2004, what is the difference between the Expenses (in $) in Canada and Expenses (in $) in Jordan?
Make the answer very short. 1.78e+1. In the year 2004, what is the difference between the Expenses (in $) in Canada and Expenses (in $) in Russian Federation?
Your response must be concise. -1.07e+12. In the year 2004, what is the difference between the Expenses (in $) in Canada and Expenses (in $) in St. Lucia?
Your answer should be compact. 1.88e+1. In the year 2004, what is the difference between the Expenses (in $) of Jordan and Expenses (in $) of Russian Federation?
Keep it short and to the point. -1.09e+12. In the year 2004, what is the difference between the Expenses (in $) of Jordan and Expenses (in $) of St. Lucia?
Offer a terse response. 1.03e+09. In the year 2004, what is the difference between the Expenses (in $) of Russian Federation and Expenses (in $) of St. Lucia?
Your answer should be very brief. 1.09e+12. In the year 2005, what is the difference between the Expenses (in $) of Canada and Expenses (in $) of Jordan?
Offer a terse response. 1.83e+1. In the year 2005, what is the difference between the Expenses (in $) of Canada and Expenses (in $) of Russian Federation?
Your answer should be very brief. -1.91e+12. In the year 2005, what is the difference between the Expenses (in $) of Canada and Expenses (in $) of St. Lucia?
Offer a very short reply. 1.92e+1. In the year 2005, what is the difference between the Expenses (in $) of Jordan and Expenses (in $) of Russian Federation?
Ensure brevity in your answer.  -1.93e+12. In the year 2005, what is the difference between the Expenses (in $) in Jordan and Expenses (in $) in St. Lucia?
Your response must be concise. 8.62e+08. In the year 2005, what is the difference between the Expenses (in $) of Russian Federation and Expenses (in $) of St. Lucia?
Provide a succinct answer. 1.93e+12. In the year 2006, what is the difference between the Expenses (in $) of Canada and Expenses (in $) of Jordan?
Give a very brief answer. 2.00e+1. In the year 2006, what is the difference between the Expenses (in $) of Canada and Expenses (in $) of Russian Federation?
Make the answer very short. -1.91e+12. In the year 2006, what is the difference between the Expenses (in $) of Canada and Expenses (in $) of St. Lucia?
Offer a terse response. 2.09e+1. In the year 2006, what is the difference between the Expenses (in $) in Jordan and Expenses (in $) in Russian Federation?
Offer a terse response. -1.93e+12. In the year 2006, what is the difference between the Expenses (in $) of Jordan and Expenses (in $) of St. Lucia?
Provide a short and direct response. 8.27e+08. In the year 2006, what is the difference between the Expenses (in $) of Russian Federation and Expenses (in $) of St. Lucia?
Provide a succinct answer. 1.93e+12. In the year 2007, what is the difference between the Expenses (in $) in Canada and Expenses (in $) in Jordan?
Keep it short and to the point. 2.35e+1. In the year 2007, what is the difference between the Expenses (in $) in Canada and Expenses (in $) in Russian Federation?
Provide a short and direct response. -2.88e+12. In the year 2007, what is the difference between the Expenses (in $) of Canada and Expenses (in $) of St. Lucia?
Your answer should be compact. 2.45e+1. In the year 2007, what is the difference between the Expenses (in $) in Jordan and Expenses (in $) in Russian Federation?
Your answer should be compact. -2.91e+12. In the year 2007, what is the difference between the Expenses (in $) in Jordan and Expenses (in $) in St. Lucia?
Provide a short and direct response. 9.49e+08. In the year 2007, what is the difference between the Expenses (in $) of Russian Federation and Expenses (in $) of St. Lucia?
Provide a short and direct response. 2.91e+12. In the year 2008, what is the difference between the Expenses (in $) of Canada and Expenses (in $) of Jordan?
Your answer should be very brief. 2.58e+1. In the year 2008, what is the difference between the Expenses (in $) in Canada and Expenses (in $) in Russian Federation?
Provide a short and direct response. -5.35e+12. In the year 2008, what is the difference between the Expenses (in $) of Canada and Expenses (in $) of St. Lucia?
Your answer should be compact. 2.77e+1. In the year 2008, what is the difference between the Expenses (in $) in Jordan and Expenses (in $) in Russian Federation?
Provide a short and direct response. -5.38e+12. In the year 2008, what is the difference between the Expenses (in $) of Jordan and Expenses (in $) of St. Lucia?
Your answer should be very brief. 1.94e+09. In the year 2008, what is the difference between the Expenses (in $) in Russian Federation and Expenses (in $) in St. Lucia?
Offer a very short reply. 5.38e+12. In the year 2009, what is the difference between the Expenses (in $) of Canada and Expenses (in $) of Jordan?
Give a very brief answer. 2.05e+1. In the year 2009, what is the difference between the Expenses (in $) of Canada and Expenses (in $) of Russian Federation?
Provide a short and direct response. -2.78e+12. In the year 2009, what is the difference between the Expenses (in $) of Canada and Expenses (in $) of St. Lucia?
Offer a very short reply. 2.21e+1. In the year 2009, what is the difference between the Expenses (in $) of Jordan and Expenses (in $) of Russian Federation?
Ensure brevity in your answer.  -2.80e+12. In the year 2009, what is the difference between the Expenses (in $) in Jordan and Expenses (in $) in St. Lucia?
Keep it short and to the point. 1.59e+09. In the year 2009, what is the difference between the Expenses (in $) in Russian Federation and Expenses (in $) in St. Lucia?
Your answer should be very brief. 2.80e+12. What is the ratio of the Expenses (in $) of Canada in 2003 to that in 2004?
Your answer should be compact. 1.13. What is the ratio of the Expenses (in $) in Russian Federation in 2003 to that in 2004?
Provide a short and direct response. 0.71. What is the ratio of the Expenses (in $) in St. Lucia in 2003 to that in 2004?
Your answer should be very brief. 7.17. What is the ratio of the Expenses (in $) of Canada in 2003 to that in 2005?
Provide a short and direct response. 1.11. What is the ratio of the Expenses (in $) of Jordan in 2003 to that in 2005?
Offer a very short reply. 1.19. What is the ratio of the Expenses (in $) in Russian Federation in 2003 to that in 2005?
Your response must be concise. 0.4. What is the ratio of the Expenses (in $) of St. Lucia in 2003 to that in 2005?
Give a very brief answer. 10.24. What is the ratio of the Expenses (in $) of Canada in 2003 to that in 2006?
Your answer should be very brief. 1.02. What is the ratio of the Expenses (in $) in Jordan in 2003 to that in 2006?
Your answer should be very brief. 1.24. What is the ratio of the Expenses (in $) in Russian Federation in 2003 to that in 2006?
Ensure brevity in your answer.  0.4. What is the ratio of the Expenses (in $) in St. Lucia in 2003 to that in 2006?
Your response must be concise. 13.03. What is the ratio of the Expenses (in $) of Canada in 2003 to that in 2007?
Provide a succinct answer. 0.87. What is the ratio of the Expenses (in $) of Jordan in 2003 to that in 2007?
Your answer should be very brief. 1.07. What is the ratio of the Expenses (in $) in Russian Federation in 2003 to that in 2007?
Your answer should be very brief. 0.27. What is the ratio of the Expenses (in $) in St. Lucia in 2003 to that in 2007?
Offer a very short reply. 4.62. What is the ratio of the Expenses (in $) in Canada in 2003 to that in 2008?
Make the answer very short. 0.77. What is the ratio of the Expenses (in $) in Jordan in 2003 to that in 2008?
Provide a short and direct response. 0.52. What is the ratio of the Expenses (in $) in Russian Federation in 2003 to that in 2008?
Your response must be concise. 0.14. What is the ratio of the Expenses (in $) of St. Lucia in 2003 to that in 2008?
Make the answer very short. 2.08. What is the ratio of the Expenses (in $) of Canada in 2003 to that in 2009?
Make the answer very short. 0.96. What is the ratio of the Expenses (in $) of Jordan in 2003 to that in 2009?
Offer a very short reply. 0.63. What is the ratio of the Expenses (in $) in Russian Federation in 2003 to that in 2009?
Keep it short and to the point. 0.28. What is the ratio of the Expenses (in $) of St. Lucia in 2003 to that in 2009?
Make the answer very short. 1.66. What is the ratio of the Expenses (in $) of Canada in 2004 to that in 2005?
Your answer should be compact. 0.98. What is the ratio of the Expenses (in $) of Jordan in 2004 to that in 2005?
Provide a short and direct response. 1.2. What is the ratio of the Expenses (in $) in Russian Federation in 2004 to that in 2005?
Your answer should be compact. 0.57. What is the ratio of the Expenses (in $) of St. Lucia in 2004 to that in 2005?
Ensure brevity in your answer.  1.43. What is the ratio of the Expenses (in $) of Canada in 2004 to that in 2006?
Your answer should be very brief. 0.9. What is the ratio of the Expenses (in $) in Jordan in 2004 to that in 2006?
Offer a very short reply. 1.25. What is the ratio of the Expenses (in $) of Russian Federation in 2004 to that in 2006?
Your answer should be very brief. 0.56. What is the ratio of the Expenses (in $) of St. Lucia in 2004 to that in 2006?
Your response must be concise. 1.82. What is the ratio of the Expenses (in $) of Canada in 2004 to that in 2007?
Your answer should be compact. 0.77. What is the ratio of the Expenses (in $) of Jordan in 2004 to that in 2007?
Make the answer very short. 1.08. What is the ratio of the Expenses (in $) of Russian Federation in 2004 to that in 2007?
Make the answer very short. 0.37. What is the ratio of the Expenses (in $) of St. Lucia in 2004 to that in 2007?
Your response must be concise. 0.65. What is the ratio of the Expenses (in $) in Canada in 2004 to that in 2008?
Your answer should be compact. 0.68. What is the ratio of the Expenses (in $) of Jordan in 2004 to that in 2008?
Offer a terse response. 0.53. What is the ratio of the Expenses (in $) in Russian Federation in 2004 to that in 2008?
Provide a succinct answer. 0.2. What is the ratio of the Expenses (in $) in St. Lucia in 2004 to that in 2008?
Provide a succinct answer. 0.29. What is the ratio of the Expenses (in $) of Canada in 2004 to that in 2009?
Offer a terse response. 0.85. What is the ratio of the Expenses (in $) of Jordan in 2004 to that in 2009?
Provide a short and direct response. 0.64. What is the ratio of the Expenses (in $) of Russian Federation in 2004 to that in 2009?
Provide a succinct answer. 0.39. What is the ratio of the Expenses (in $) of St. Lucia in 2004 to that in 2009?
Offer a terse response. 0.23. What is the ratio of the Expenses (in $) of Canada in 2005 to that in 2006?
Make the answer very short. 0.92. What is the ratio of the Expenses (in $) of Jordan in 2005 to that in 2006?
Your answer should be very brief. 1.04. What is the ratio of the Expenses (in $) of St. Lucia in 2005 to that in 2006?
Make the answer very short. 1.27. What is the ratio of the Expenses (in $) in Canada in 2005 to that in 2007?
Give a very brief answer. 0.78. What is the ratio of the Expenses (in $) of Jordan in 2005 to that in 2007?
Offer a very short reply. 0.9. What is the ratio of the Expenses (in $) of Russian Federation in 2005 to that in 2007?
Offer a very short reply. 0.66. What is the ratio of the Expenses (in $) in St. Lucia in 2005 to that in 2007?
Make the answer very short. 0.45. What is the ratio of the Expenses (in $) of Canada in 2005 to that in 2008?
Ensure brevity in your answer.  0.69. What is the ratio of the Expenses (in $) in Jordan in 2005 to that in 2008?
Offer a very short reply. 0.44. What is the ratio of the Expenses (in $) in Russian Federation in 2005 to that in 2008?
Offer a terse response. 0.36. What is the ratio of the Expenses (in $) of St. Lucia in 2005 to that in 2008?
Provide a succinct answer. 0.2. What is the ratio of the Expenses (in $) of Canada in 2005 to that in 2009?
Ensure brevity in your answer.  0.87. What is the ratio of the Expenses (in $) of Jordan in 2005 to that in 2009?
Offer a very short reply. 0.53. What is the ratio of the Expenses (in $) of Russian Federation in 2005 to that in 2009?
Provide a short and direct response. 0.69. What is the ratio of the Expenses (in $) of St. Lucia in 2005 to that in 2009?
Ensure brevity in your answer.  0.16. What is the ratio of the Expenses (in $) in Canada in 2006 to that in 2007?
Make the answer very short. 0.85. What is the ratio of the Expenses (in $) of Jordan in 2006 to that in 2007?
Your answer should be very brief. 0.87. What is the ratio of the Expenses (in $) in Russian Federation in 2006 to that in 2007?
Your answer should be very brief. 0.66. What is the ratio of the Expenses (in $) of St. Lucia in 2006 to that in 2007?
Your answer should be compact. 0.35. What is the ratio of the Expenses (in $) in Canada in 2006 to that in 2008?
Your answer should be compact. 0.75. What is the ratio of the Expenses (in $) of Jordan in 2006 to that in 2008?
Your answer should be compact. 0.42. What is the ratio of the Expenses (in $) of Russian Federation in 2006 to that in 2008?
Your answer should be compact. 0.36. What is the ratio of the Expenses (in $) in St. Lucia in 2006 to that in 2008?
Keep it short and to the point. 0.16. What is the ratio of the Expenses (in $) of Canada in 2006 to that in 2009?
Offer a very short reply. 0.94. What is the ratio of the Expenses (in $) in Jordan in 2006 to that in 2009?
Give a very brief answer. 0.51. What is the ratio of the Expenses (in $) in Russian Federation in 2006 to that in 2009?
Offer a very short reply. 0.69. What is the ratio of the Expenses (in $) in St. Lucia in 2006 to that in 2009?
Your response must be concise. 0.13. What is the ratio of the Expenses (in $) of Canada in 2007 to that in 2008?
Your answer should be compact. 0.88. What is the ratio of the Expenses (in $) of Jordan in 2007 to that in 2008?
Offer a terse response. 0.49. What is the ratio of the Expenses (in $) of Russian Federation in 2007 to that in 2008?
Provide a succinct answer. 0.54. What is the ratio of the Expenses (in $) in St. Lucia in 2007 to that in 2008?
Keep it short and to the point. 0.45. What is the ratio of the Expenses (in $) of Canada in 2007 to that in 2009?
Make the answer very short. 1.11. What is the ratio of the Expenses (in $) of Jordan in 2007 to that in 2009?
Keep it short and to the point. 0.59. What is the ratio of the Expenses (in $) of Russian Federation in 2007 to that in 2009?
Your answer should be compact. 1.04. What is the ratio of the Expenses (in $) of St. Lucia in 2007 to that in 2009?
Provide a short and direct response. 0.36. What is the ratio of the Expenses (in $) in Canada in 2008 to that in 2009?
Provide a succinct answer. 1.25. What is the ratio of the Expenses (in $) of Jordan in 2008 to that in 2009?
Your response must be concise. 1.21. What is the ratio of the Expenses (in $) in Russian Federation in 2008 to that in 2009?
Offer a terse response. 1.92. What is the ratio of the Expenses (in $) of St. Lucia in 2008 to that in 2009?
Provide a short and direct response. 0.8. What is the difference between the highest and the second highest Expenses (in $) in Canada?
Give a very brief answer. 3.24e+09. What is the difference between the highest and the second highest Expenses (in $) in Jordan?
Ensure brevity in your answer.  3.38e+08. What is the difference between the highest and the second highest Expenses (in $) of Russian Federation?
Offer a terse response. 2.47e+12. What is the difference between the highest and the second highest Expenses (in $) of St. Lucia?
Your answer should be very brief. 1.71e+07. What is the difference between the highest and the lowest Expenses (in $) in Canada?
Offer a terse response. 8.90e+09. What is the difference between the highest and the lowest Expenses (in $) of Jordan?
Offer a terse response. 1.13e+09. What is the difference between the highest and the lowest Expenses (in $) of Russian Federation?
Ensure brevity in your answer.  4.60e+12. What is the difference between the highest and the lowest Expenses (in $) in St. Lucia?
Provide a succinct answer. 3.97e+07. 